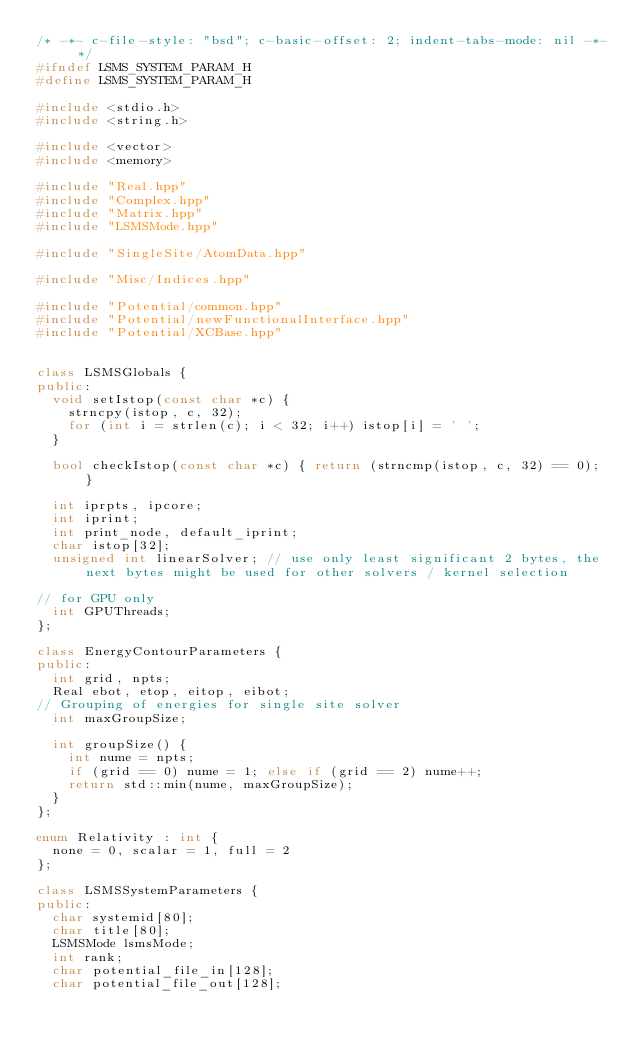Convert code to text. <code><loc_0><loc_0><loc_500><loc_500><_C++_>/* -*- c-file-style: "bsd"; c-basic-offset: 2; indent-tabs-mode: nil -*- */
#ifndef LSMS_SYSTEM_PARAM_H
#define LSMS_SYSTEM_PARAM_H

#include <stdio.h>
#include <string.h>

#include <vector>
#include <memory>

#include "Real.hpp"
#include "Complex.hpp"
#include "Matrix.hpp"
#include "LSMSMode.hpp"

#include "SingleSite/AtomData.hpp"

#include "Misc/Indices.hpp"

#include "Potential/common.hpp"
#include "Potential/newFunctionalInterface.hpp"
#include "Potential/XCBase.hpp"


class LSMSGlobals {
public:
  void setIstop(const char *c) {
    strncpy(istop, c, 32);
    for (int i = strlen(c); i < 32; i++) istop[i] = ' ';
  }

  bool checkIstop(const char *c) { return (strncmp(istop, c, 32) == 0); }

  int iprpts, ipcore;
  int iprint;
  int print_node, default_iprint;
  char istop[32];
  unsigned int linearSolver; // use only least significant 2 bytes, the next bytes might be used for other solvers / kernel selection

// for GPU only
  int GPUThreads;
};

class EnergyContourParameters {
public:
  int grid, npts;
  Real ebot, etop, eitop, eibot;
// Grouping of energies for single site solver
  int maxGroupSize;

  int groupSize() {
    int nume = npts;
    if (grid == 0) nume = 1; else if (grid == 2) nume++;
    return std::min(nume, maxGroupSize);
  }
};

enum Relativity : int {
  none = 0, scalar = 1, full = 2
};

class LSMSSystemParameters {
public:
  char systemid[80];
  char title[80];
  LSMSMode lsmsMode;
  int rank;
  char potential_file_in[128];
  char potential_file_out[128];</code> 